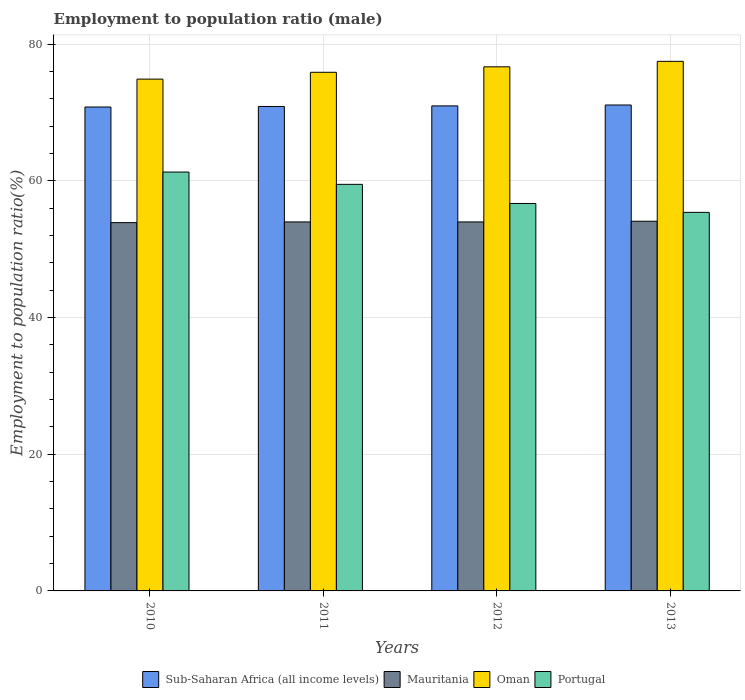How many different coloured bars are there?
Provide a short and direct response. 4. How many groups of bars are there?
Provide a succinct answer. 4. Are the number of bars per tick equal to the number of legend labels?
Make the answer very short. Yes. Are the number of bars on each tick of the X-axis equal?
Your answer should be compact. Yes. How many bars are there on the 4th tick from the left?
Your answer should be compact. 4. How many bars are there on the 3rd tick from the right?
Give a very brief answer. 4. What is the employment to population ratio in Portugal in 2011?
Provide a succinct answer. 59.5. Across all years, what is the maximum employment to population ratio in Oman?
Make the answer very short. 77.5. Across all years, what is the minimum employment to population ratio in Portugal?
Ensure brevity in your answer.  55.4. What is the total employment to population ratio in Portugal in the graph?
Your answer should be very brief. 232.9. What is the difference between the employment to population ratio in Mauritania in 2010 and that in 2011?
Ensure brevity in your answer.  -0.1. What is the difference between the employment to population ratio in Oman in 2010 and the employment to population ratio in Portugal in 2012?
Offer a terse response. 18.2. What is the average employment to population ratio in Portugal per year?
Your answer should be very brief. 58.23. In the year 2011, what is the difference between the employment to population ratio in Sub-Saharan Africa (all income levels) and employment to population ratio in Mauritania?
Offer a terse response. 16.9. In how many years, is the employment to population ratio in Oman greater than 44 %?
Offer a very short reply. 4. What is the ratio of the employment to population ratio in Portugal in 2010 to that in 2012?
Provide a short and direct response. 1.08. What is the difference between the highest and the second highest employment to population ratio in Mauritania?
Give a very brief answer. 0.1. What is the difference between the highest and the lowest employment to population ratio in Oman?
Make the answer very short. 2.6. In how many years, is the employment to population ratio in Portugal greater than the average employment to population ratio in Portugal taken over all years?
Give a very brief answer. 2. Is it the case that in every year, the sum of the employment to population ratio in Oman and employment to population ratio in Sub-Saharan Africa (all income levels) is greater than the sum of employment to population ratio in Mauritania and employment to population ratio in Portugal?
Ensure brevity in your answer.  Yes. What does the 2nd bar from the left in 2011 represents?
Ensure brevity in your answer.  Mauritania. What does the 2nd bar from the right in 2011 represents?
Your response must be concise. Oman. Is it the case that in every year, the sum of the employment to population ratio in Portugal and employment to population ratio in Mauritania is greater than the employment to population ratio in Sub-Saharan Africa (all income levels)?
Your answer should be compact. Yes. How many bars are there?
Your answer should be very brief. 16. How many years are there in the graph?
Your answer should be very brief. 4. What is the difference between two consecutive major ticks on the Y-axis?
Your answer should be very brief. 20. Are the values on the major ticks of Y-axis written in scientific E-notation?
Provide a succinct answer. No. Does the graph contain any zero values?
Keep it short and to the point. No. How are the legend labels stacked?
Provide a succinct answer. Horizontal. What is the title of the graph?
Keep it short and to the point. Employment to population ratio (male). What is the label or title of the Y-axis?
Keep it short and to the point. Employment to population ratio(%). What is the Employment to population ratio(%) of Sub-Saharan Africa (all income levels) in 2010?
Your answer should be very brief. 70.82. What is the Employment to population ratio(%) of Mauritania in 2010?
Keep it short and to the point. 53.9. What is the Employment to population ratio(%) of Oman in 2010?
Your answer should be very brief. 74.9. What is the Employment to population ratio(%) in Portugal in 2010?
Keep it short and to the point. 61.3. What is the Employment to population ratio(%) in Sub-Saharan Africa (all income levels) in 2011?
Ensure brevity in your answer.  70.9. What is the Employment to population ratio(%) of Mauritania in 2011?
Your answer should be compact. 54. What is the Employment to population ratio(%) of Oman in 2011?
Give a very brief answer. 75.9. What is the Employment to population ratio(%) of Portugal in 2011?
Your answer should be very brief. 59.5. What is the Employment to population ratio(%) of Sub-Saharan Africa (all income levels) in 2012?
Your answer should be very brief. 70.98. What is the Employment to population ratio(%) of Oman in 2012?
Offer a terse response. 76.7. What is the Employment to population ratio(%) in Portugal in 2012?
Ensure brevity in your answer.  56.7. What is the Employment to population ratio(%) in Sub-Saharan Africa (all income levels) in 2013?
Make the answer very short. 71.11. What is the Employment to population ratio(%) of Mauritania in 2013?
Offer a terse response. 54.1. What is the Employment to population ratio(%) of Oman in 2013?
Make the answer very short. 77.5. What is the Employment to population ratio(%) of Portugal in 2013?
Give a very brief answer. 55.4. Across all years, what is the maximum Employment to population ratio(%) of Sub-Saharan Africa (all income levels)?
Make the answer very short. 71.11. Across all years, what is the maximum Employment to population ratio(%) in Mauritania?
Ensure brevity in your answer.  54.1. Across all years, what is the maximum Employment to population ratio(%) in Oman?
Provide a short and direct response. 77.5. Across all years, what is the maximum Employment to population ratio(%) of Portugal?
Keep it short and to the point. 61.3. Across all years, what is the minimum Employment to population ratio(%) in Sub-Saharan Africa (all income levels)?
Keep it short and to the point. 70.82. Across all years, what is the minimum Employment to population ratio(%) in Mauritania?
Make the answer very short. 53.9. Across all years, what is the minimum Employment to population ratio(%) in Oman?
Your response must be concise. 74.9. Across all years, what is the minimum Employment to population ratio(%) in Portugal?
Provide a succinct answer. 55.4. What is the total Employment to population ratio(%) of Sub-Saharan Africa (all income levels) in the graph?
Provide a succinct answer. 283.81. What is the total Employment to population ratio(%) in Mauritania in the graph?
Your response must be concise. 216. What is the total Employment to population ratio(%) in Oman in the graph?
Keep it short and to the point. 305. What is the total Employment to population ratio(%) in Portugal in the graph?
Provide a succinct answer. 232.9. What is the difference between the Employment to population ratio(%) of Sub-Saharan Africa (all income levels) in 2010 and that in 2011?
Offer a very short reply. -0.08. What is the difference between the Employment to population ratio(%) of Mauritania in 2010 and that in 2011?
Your response must be concise. -0.1. What is the difference between the Employment to population ratio(%) in Sub-Saharan Africa (all income levels) in 2010 and that in 2012?
Your response must be concise. -0.16. What is the difference between the Employment to population ratio(%) of Mauritania in 2010 and that in 2012?
Your answer should be compact. -0.1. What is the difference between the Employment to population ratio(%) in Portugal in 2010 and that in 2012?
Make the answer very short. 4.6. What is the difference between the Employment to population ratio(%) in Sub-Saharan Africa (all income levels) in 2010 and that in 2013?
Offer a very short reply. -0.3. What is the difference between the Employment to population ratio(%) in Oman in 2010 and that in 2013?
Keep it short and to the point. -2.6. What is the difference between the Employment to population ratio(%) of Portugal in 2010 and that in 2013?
Your response must be concise. 5.9. What is the difference between the Employment to population ratio(%) of Sub-Saharan Africa (all income levels) in 2011 and that in 2012?
Provide a succinct answer. -0.09. What is the difference between the Employment to population ratio(%) in Portugal in 2011 and that in 2012?
Your answer should be compact. 2.8. What is the difference between the Employment to population ratio(%) of Sub-Saharan Africa (all income levels) in 2011 and that in 2013?
Your answer should be very brief. -0.22. What is the difference between the Employment to population ratio(%) of Sub-Saharan Africa (all income levels) in 2012 and that in 2013?
Your answer should be compact. -0.13. What is the difference between the Employment to population ratio(%) in Mauritania in 2012 and that in 2013?
Keep it short and to the point. -0.1. What is the difference between the Employment to population ratio(%) in Portugal in 2012 and that in 2013?
Ensure brevity in your answer.  1.3. What is the difference between the Employment to population ratio(%) of Sub-Saharan Africa (all income levels) in 2010 and the Employment to population ratio(%) of Mauritania in 2011?
Make the answer very short. 16.82. What is the difference between the Employment to population ratio(%) of Sub-Saharan Africa (all income levels) in 2010 and the Employment to population ratio(%) of Oman in 2011?
Make the answer very short. -5.08. What is the difference between the Employment to population ratio(%) of Sub-Saharan Africa (all income levels) in 2010 and the Employment to population ratio(%) of Portugal in 2011?
Your answer should be very brief. 11.32. What is the difference between the Employment to population ratio(%) of Sub-Saharan Africa (all income levels) in 2010 and the Employment to population ratio(%) of Mauritania in 2012?
Offer a terse response. 16.82. What is the difference between the Employment to population ratio(%) in Sub-Saharan Africa (all income levels) in 2010 and the Employment to population ratio(%) in Oman in 2012?
Your answer should be very brief. -5.88. What is the difference between the Employment to population ratio(%) in Sub-Saharan Africa (all income levels) in 2010 and the Employment to population ratio(%) in Portugal in 2012?
Ensure brevity in your answer.  14.12. What is the difference between the Employment to population ratio(%) in Mauritania in 2010 and the Employment to population ratio(%) in Oman in 2012?
Your response must be concise. -22.8. What is the difference between the Employment to population ratio(%) in Mauritania in 2010 and the Employment to population ratio(%) in Portugal in 2012?
Offer a terse response. -2.8. What is the difference between the Employment to population ratio(%) in Sub-Saharan Africa (all income levels) in 2010 and the Employment to population ratio(%) in Mauritania in 2013?
Provide a succinct answer. 16.72. What is the difference between the Employment to population ratio(%) in Sub-Saharan Africa (all income levels) in 2010 and the Employment to population ratio(%) in Oman in 2013?
Provide a short and direct response. -6.68. What is the difference between the Employment to population ratio(%) in Sub-Saharan Africa (all income levels) in 2010 and the Employment to population ratio(%) in Portugal in 2013?
Your answer should be compact. 15.42. What is the difference between the Employment to population ratio(%) in Mauritania in 2010 and the Employment to population ratio(%) in Oman in 2013?
Your answer should be compact. -23.6. What is the difference between the Employment to population ratio(%) in Mauritania in 2010 and the Employment to population ratio(%) in Portugal in 2013?
Make the answer very short. -1.5. What is the difference between the Employment to population ratio(%) in Oman in 2010 and the Employment to population ratio(%) in Portugal in 2013?
Your response must be concise. 19.5. What is the difference between the Employment to population ratio(%) of Sub-Saharan Africa (all income levels) in 2011 and the Employment to population ratio(%) of Mauritania in 2012?
Your answer should be very brief. 16.9. What is the difference between the Employment to population ratio(%) of Sub-Saharan Africa (all income levels) in 2011 and the Employment to population ratio(%) of Oman in 2012?
Provide a short and direct response. -5.8. What is the difference between the Employment to population ratio(%) in Sub-Saharan Africa (all income levels) in 2011 and the Employment to population ratio(%) in Portugal in 2012?
Offer a terse response. 14.2. What is the difference between the Employment to population ratio(%) in Mauritania in 2011 and the Employment to population ratio(%) in Oman in 2012?
Ensure brevity in your answer.  -22.7. What is the difference between the Employment to population ratio(%) in Sub-Saharan Africa (all income levels) in 2011 and the Employment to population ratio(%) in Mauritania in 2013?
Ensure brevity in your answer.  16.8. What is the difference between the Employment to population ratio(%) in Sub-Saharan Africa (all income levels) in 2011 and the Employment to population ratio(%) in Oman in 2013?
Make the answer very short. -6.6. What is the difference between the Employment to population ratio(%) of Sub-Saharan Africa (all income levels) in 2011 and the Employment to population ratio(%) of Portugal in 2013?
Offer a very short reply. 15.5. What is the difference between the Employment to population ratio(%) of Mauritania in 2011 and the Employment to population ratio(%) of Oman in 2013?
Your answer should be very brief. -23.5. What is the difference between the Employment to population ratio(%) in Sub-Saharan Africa (all income levels) in 2012 and the Employment to population ratio(%) in Mauritania in 2013?
Offer a terse response. 16.88. What is the difference between the Employment to population ratio(%) in Sub-Saharan Africa (all income levels) in 2012 and the Employment to population ratio(%) in Oman in 2013?
Offer a terse response. -6.52. What is the difference between the Employment to population ratio(%) of Sub-Saharan Africa (all income levels) in 2012 and the Employment to population ratio(%) of Portugal in 2013?
Offer a terse response. 15.58. What is the difference between the Employment to population ratio(%) of Mauritania in 2012 and the Employment to population ratio(%) of Oman in 2013?
Provide a succinct answer. -23.5. What is the difference between the Employment to population ratio(%) of Oman in 2012 and the Employment to population ratio(%) of Portugal in 2013?
Your answer should be very brief. 21.3. What is the average Employment to population ratio(%) of Sub-Saharan Africa (all income levels) per year?
Your response must be concise. 70.95. What is the average Employment to population ratio(%) of Mauritania per year?
Keep it short and to the point. 54. What is the average Employment to population ratio(%) in Oman per year?
Your response must be concise. 76.25. What is the average Employment to population ratio(%) of Portugal per year?
Offer a very short reply. 58.23. In the year 2010, what is the difference between the Employment to population ratio(%) of Sub-Saharan Africa (all income levels) and Employment to population ratio(%) of Mauritania?
Offer a very short reply. 16.92. In the year 2010, what is the difference between the Employment to population ratio(%) of Sub-Saharan Africa (all income levels) and Employment to population ratio(%) of Oman?
Your answer should be compact. -4.08. In the year 2010, what is the difference between the Employment to population ratio(%) in Sub-Saharan Africa (all income levels) and Employment to population ratio(%) in Portugal?
Make the answer very short. 9.52. In the year 2010, what is the difference between the Employment to population ratio(%) of Mauritania and Employment to population ratio(%) of Oman?
Make the answer very short. -21. In the year 2010, what is the difference between the Employment to population ratio(%) in Mauritania and Employment to population ratio(%) in Portugal?
Offer a very short reply. -7.4. In the year 2010, what is the difference between the Employment to population ratio(%) of Oman and Employment to population ratio(%) of Portugal?
Your answer should be compact. 13.6. In the year 2011, what is the difference between the Employment to population ratio(%) of Sub-Saharan Africa (all income levels) and Employment to population ratio(%) of Mauritania?
Your answer should be compact. 16.9. In the year 2011, what is the difference between the Employment to population ratio(%) of Sub-Saharan Africa (all income levels) and Employment to population ratio(%) of Oman?
Your response must be concise. -5. In the year 2011, what is the difference between the Employment to population ratio(%) of Sub-Saharan Africa (all income levels) and Employment to population ratio(%) of Portugal?
Provide a short and direct response. 11.4. In the year 2011, what is the difference between the Employment to population ratio(%) in Mauritania and Employment to population ratio(%) in Oman?
Offer a terse response. -21.9. In the year 2011, what is the difference between the Employment to population ratio(%) of Mauritania and Employment to population ratio(%) of Portugal?
Offer a terse response. -5.5. In the year 2011, what is the difference between the Employment to population ratio(%) in Oman and Employment to population ratio(%) in Portugal?
Offer a very short reply. 16.4. In the year 2012, what is the difference between the Employment to population ratio(%) of Sub-Saharan Africa (all income levels) and Employment to population ratio(%) of Mauritania?
Provide a short and direct response. 16.98. In the year 2012, what is the difference between the Employment to population ratio(%) in Sub-Saharan Africa (all income levels) and Employment to population ratio(%) in Oman?
Ensure brevity in your answer.  -5.72. In the year 2012, what is the difference between the Employment to population ratio(%) of Sub-Saharan Africa (all income levels) and Employment to population ratio(%) of Portugal?
Offer a terse response. 14.28. In the year 2012, what is the difference between the Employment to population ratio(%) in Mauritania and Employment to population ratio(%) in Oman?
Your answer should be very brief. -22.7. In the year 2013, what is the difference between the Employment to population ratio(%) in Sub-Saharan Africa (all income levels) and Employment to population ratio(%) in Mauritania?
Offer a very short reply. 17.01. In the year 2013, what is the difference between the Employment to population ratio(%) in Sub-Saharan Africa (all income levels) and Employment to population ratio(%) in Oman?
Give a very brief answer. -6.39. In the year 2013, what is the difference between the Employment to population ratio(%) of Sub-Saharan Africa (all income levels) and Employment to population ratio(%) of Portugal?
Provide a succinct answer. 15.71. In the year 2013, what is the difference between the Employment to population ratio(%) of Mauritania and Employment to population ratio(%) of Oman?
Keep it short and to the point. -23.4. In the year 2013, what is the difference between the Employment to population ratio(%) in Oman and Employment to population ratio(%) in Portugal?
Ensure brevity in your answer.  22.1. What is the ratio of the Employment to population ratio(%) in Sub-Saharan Africa (all income levels) in 2010 to that in 2011?
Provide a short and direct response. 1. What is the ratio of the Employment to population ratio(%) of Oman in 2010 to that in 2011?
Your response must be concise. 0.99. What is the ratio of the Employment to population ratio(%) in Portugal in 2010 to that in 2011?
Your response must be concise. 1.03. What is the ratio of the Employment to population ratio(%) of Sub-Saharan Africa (all income levels) in 2010 to that in 2012?
Your answer should be compact. 1. What is the ratio of the Employment to population ratio(%) of Mauritania in 2010 to that in 2012?
Provide a succinct answer. 1. What is the ratio of the Employment to population ratio(%) in Oman in 2010 to that in 2012?
Ensure brevity in your answer.  0.98. What is the ratio of the Employment to population ratio(%) of Portugal in 2010 to that in 2012?
Make the answer very short. 1.08. What is the ratio of the Employment to population ratio(%) of Mauritania in 2010 to that in 2013?
Provide a succinct answer. 1. What is the ratio of the Employment to population ratio(%) in Oman in 2010 to that in 2013?
Keep it short and to the point. 0.97. What is the ratio of the Employment to population ratio(%) in Portugal in 2010 to that in 2013?
Keep it short and to the point. 1.11. What is the ratio of the Employment to population ratio(%) of Portugal in 2011 to that in 2012?
Provide a short and direct response. 1.05. What is the ratio of the Employment to population ratio(%) in Sub-Saharan Africa (all income levels) in 2011 to that in 2013?
Provide a short and direct response. 1. What is the ratio of the Employment to population ratio(%) of Oman in 2011 to that in 2013?
Your answer should be compact. 0.98. What is the ratio of the Employment to population ratio(%) of Portugal in 2011 to that in 2013?
Make the answer very short. 1.07. What is the ratio of the Employment to population ratio(%) of Sub-Saharan Africa (all income levels) in 2012 to that in 2013?
Keep it short and to the point. 1. What is the ratio of the Employment to population ratio(%) of Oman in 2012 to that in 2013?
Ensure brevity in your answer.  0.99. What is the ratio of the Employment to population ratio(%) in Portugal in 2012 to that in 2013?
Keep it short and to the point. 1.02. What is the difference between the highest and the second highest Employment to population ratio(%) in Sub-Saharan Africa (all income levels)?
Keep it short and to the point. 0.13. What is the difference between the highest and the second highest Employment to population ratio(%) in Mauritania?
Your answer should be compact. 0.1. What is the difference between the highest and the second highest Employment to population ratio(%) of Oman?
Keep it short and to the point. 0.8. What is the difference between the highest and the second highest Employment to population ratio(%) of Portugal?
Ensure brevity in your answer.  1.8. What is the difference between the highest and the lowest Employment to population ratio(%) of Sub-Saharan Africa (all income levels)?
Your answer should be compact. 0.3. 